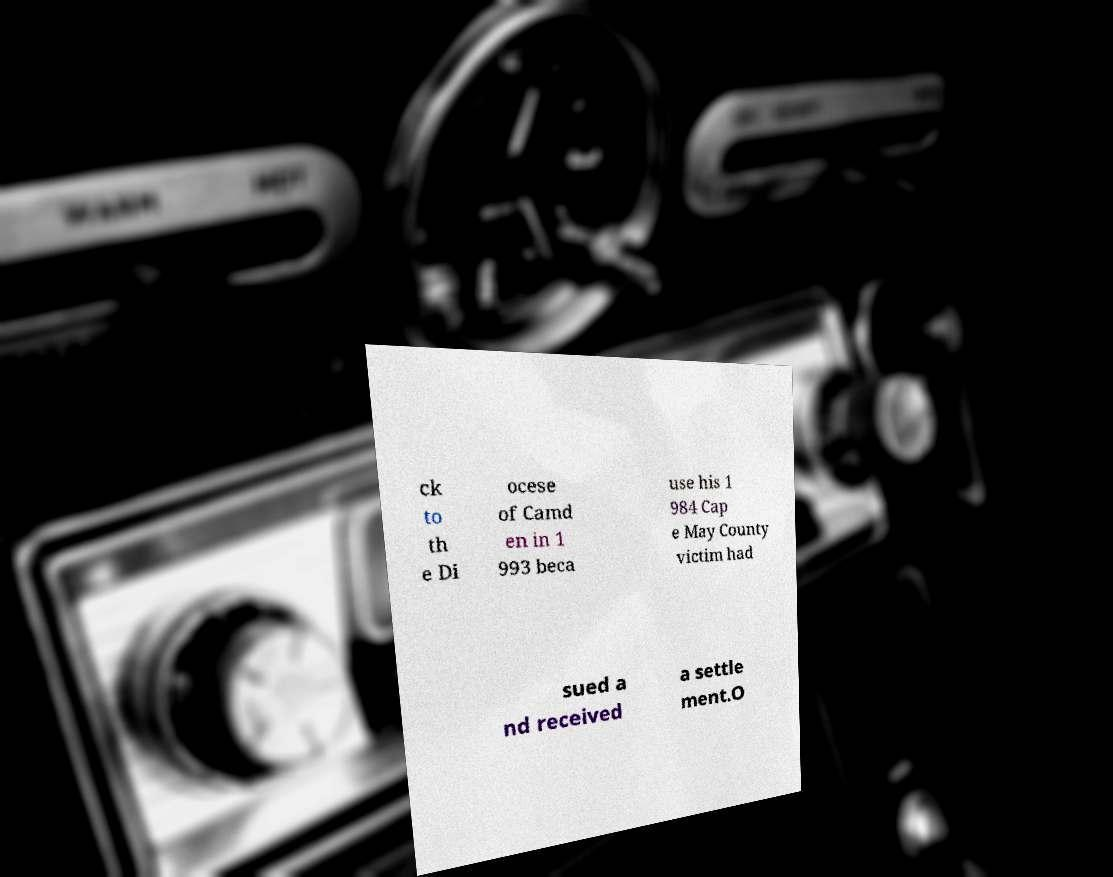Can you accurately transcribe the text from the provided image for me? ck to th e Di ocese of Camd en in 1 993 beca use his 1 984 Cap e May County victim had sued a nd received a settle ment.O 